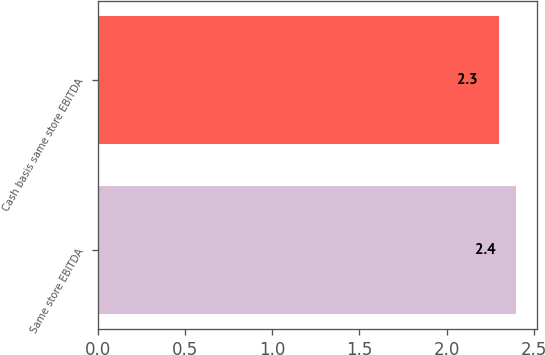Convert chart to OTSL. <chart><loc_0><loc_0><loc_500><loc_500><bar_chart><fcel>Same store EBITDA<fcel>Cash basis same store EBITDA<nl><fcel>2.4<fcel>2.3<nl></chart> 